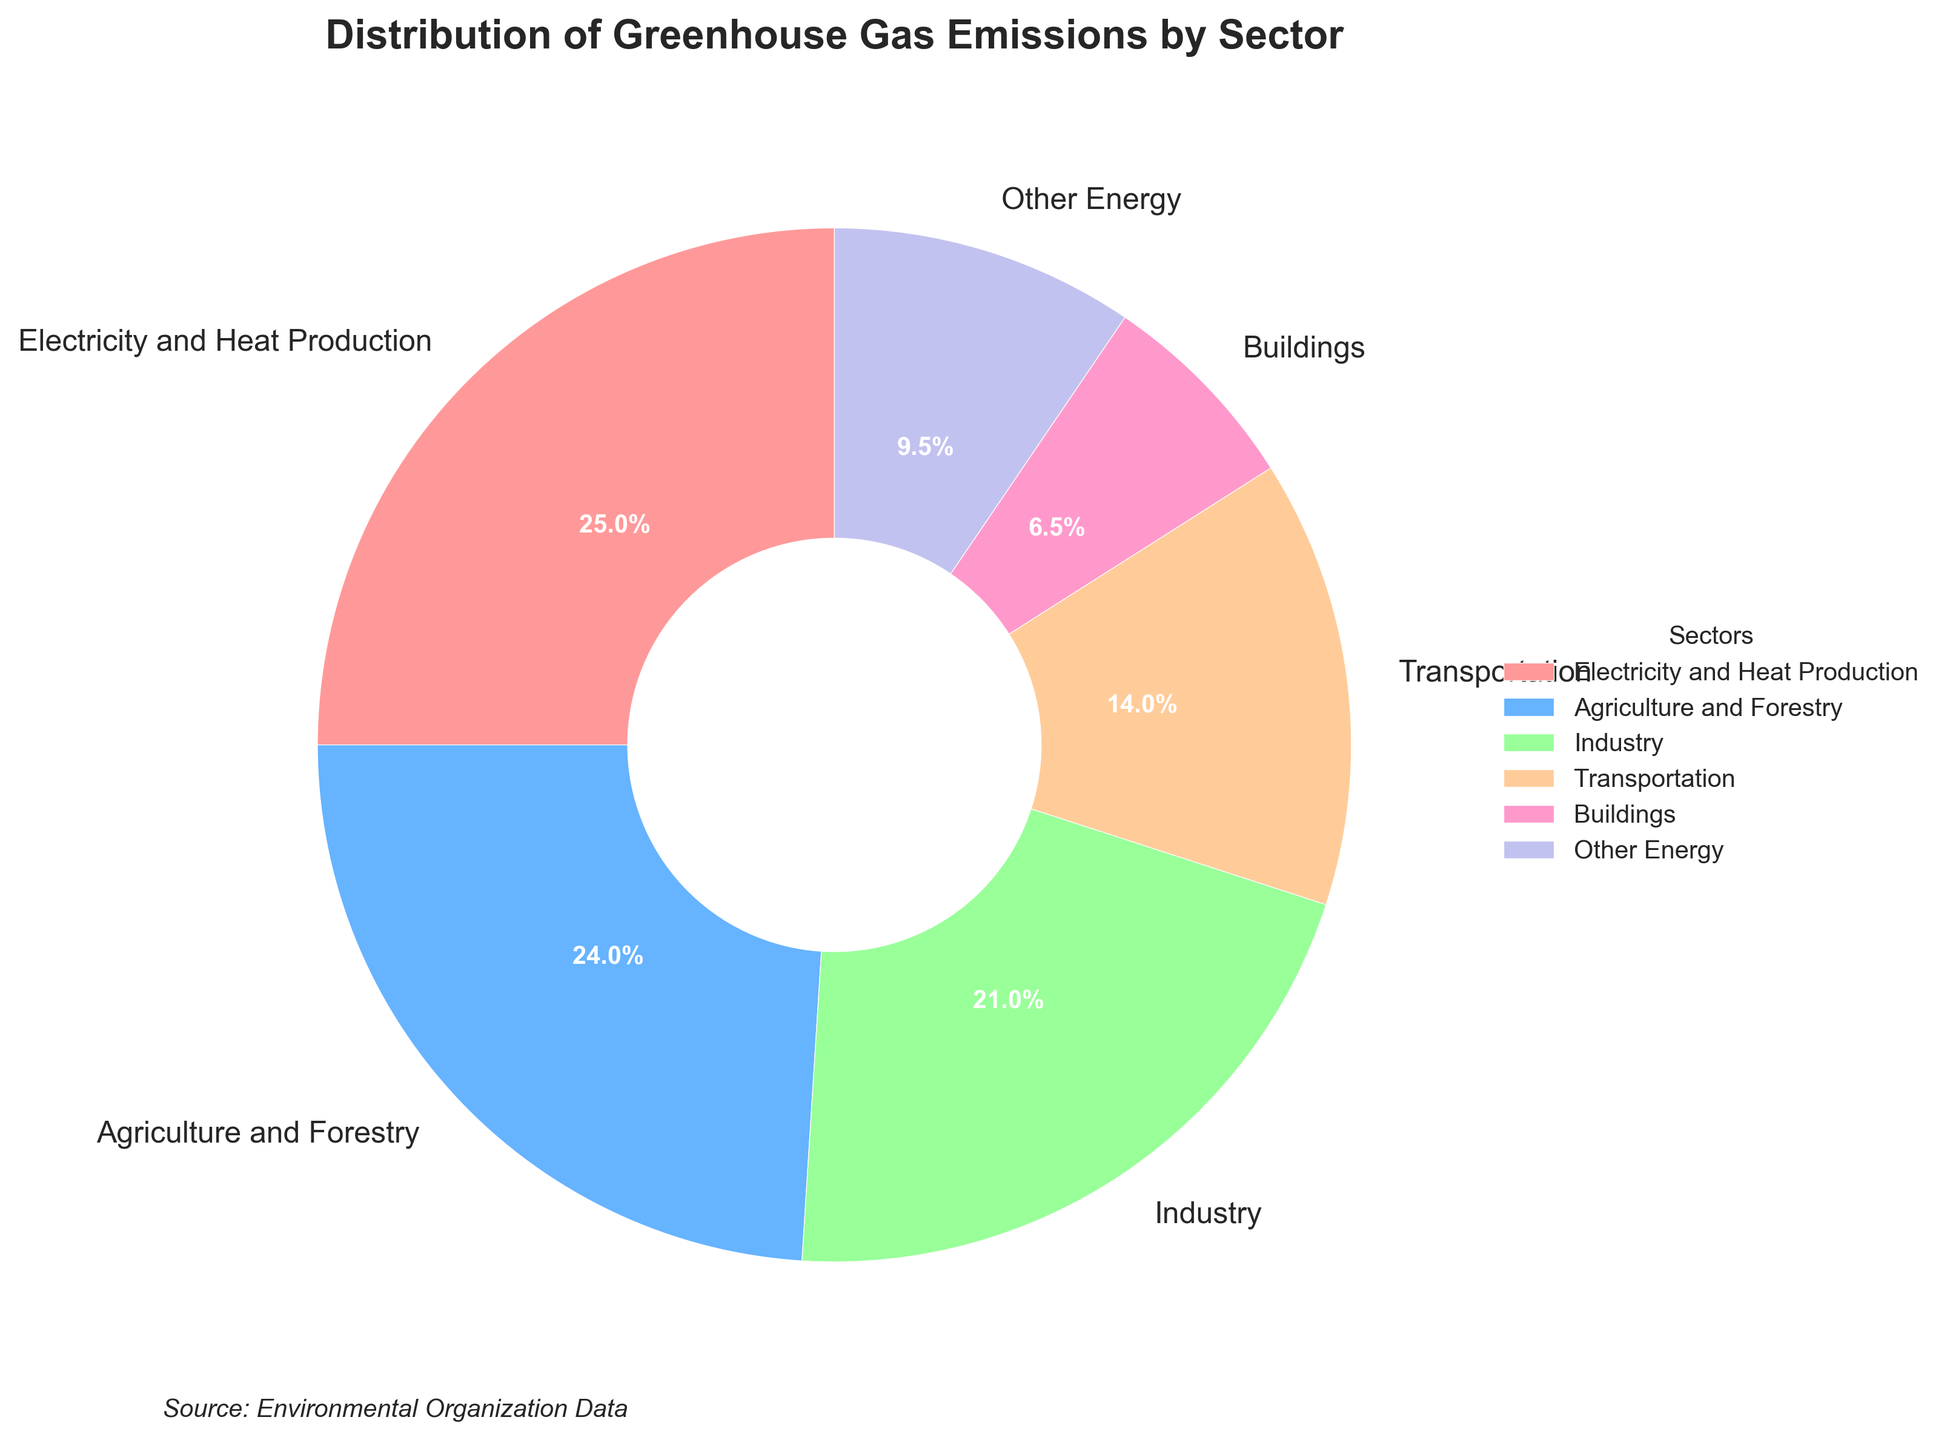What sector produces the highest percentage of greenhouse gas emissions? Look at the pie chart and identify the sector with the largest wedge. The "Electricity and Heat Production" sector has the largest wedge at 25.0%.
Answer: Electricity and Heat Production Which two sectors combined account for nearly half of the greenhouse gas emissions? Summing the percentages of various sectors, the first two sectors that get close to 50% are "Electricity and Heat Production" (25.0%) and "Agriculture and Forestry" (24.0%). Together, they account for 49.0%.
Answer: Electricity and Heat Production and Agriculture and Forestry Is the percentage of emissions from Industry greater than that from Transportation? Compare the wedges representing "Industry" and "Transportation". Industry is 21.0% whereas Transportation is 14.0%.
Answer: Yes Which sector has a smaller percentage of greenhouse gas emissions: Buildings or Other Energy? Observe the pie chart wedges for Buildings (6.5%) and Other Energy (9.5%). Buildings have a smaller wedge.
Answer: Buildings How much larger is the percentage of emissions from Agriculture and Forestry compared to the Buildings sector? Subtract the percentage of Buildings from Agriculture and Forestry: 24.0% - 6.5% = 17.5%.
Answer: 17.5% What is the sum of the percentages for Industry and Other Energy? Add the percentages of Industry (21.0%) and Other Energy (9.5%): 21.0% + 9.5% = 30.5%.
Answer: 30.5% Which sector's wedge is represented by the pink color? Visually identify the pink wedge in the pie chart. The sector closest to pink is "Electricity and Heat Production."
Answer: Electricity and Heat Production Is Transportation responsible for more emissions than Buildings? Compare the emission percentages of Transportation (14.0%) and Buildings (6.5%). Transportation has a higher percentage.
Answer: Yes 